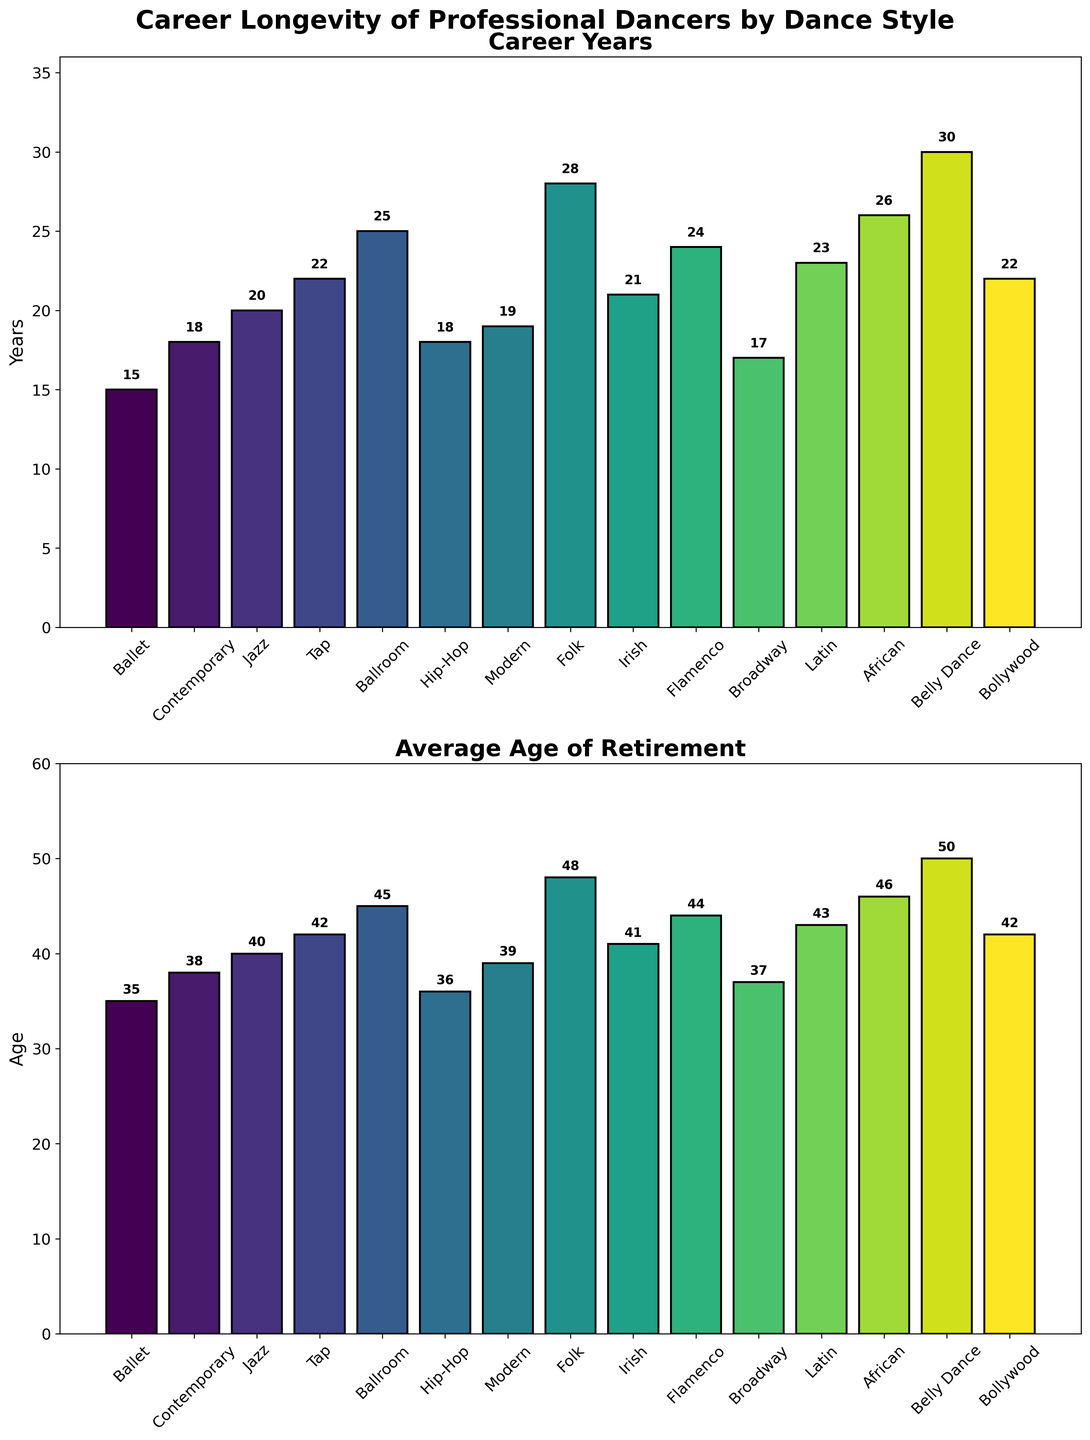What is the average career length for hip-hop dancers? Starting from the top figure, we find the bar for hip-hop. The bar indicates the career years for hip-hop dancers is 18.
Answer: 18 Which dance style has the highest average age of retirement? Looking at the bottom figure, the tallest bar represents the highest average age of retirement. The bar for Belly Dance is the tallest, indicating the age is 50.
Answer: Belly Dance, 50 Which dance styles have career lengths greater than 20 years? In the top figure, we identify bars that extend beyond the 20-year mark. These styles are Tap, Ballroom, Folk, Belly Dance, Flamenco, Latin, and African.
Answer: Tap, Ballroom, Folk, Belly Dance, Flamenco, Latin, African What is the difference in career length between Ballet and Contemporary dancers? From the top figure, we see that Ballet dancers have a career length of 15 years and Contemporary dancers have 18 years. The difference is calculated by subtracting 15 from 18, which equals 3.
Answer: 3 years How many dance styles have an average retirement age of 40 or above? In the bottom figure, we count the bars representing retirement ages of 40 or more. These styles are Jazz, Tap, Ballroom, Hip-Hop, Modern, Folk, Irish, Flamenco, Broadway, Latin, African, Belly Dance, Bollywood. Thus, there are 13 dance styles.
Answer: 13 styles Which dance style has the shortest career length, and what is it? In the top figure, the shortest bar represents the shortest career length. This is for Ballet, with a career length of 15 years.
Answer: Ballet, 15 years Compare the average age of retirement between Modern and Hip-Hop dancers. Which is greater? From the bottom figure, we find that Modern dancers retire at an average age of 39, while Hip-Hop dancers retire at an average age of 36. Therefore, Modern dancers have a greater average retirement age.
Answer: Modern, 39 What is the combined career length for Tap and Bollywood dancers? From the top figure, Tap dancers have a career length of 22 years and Bollywood dancers have a career length of 22 years. The combined length is 22 + 22 = 44 years.
Answer: 44 years Calculate the average career length across all dance styles. Summing up all career lengths from the top figure: 15 (Ballet) + 18 (Contemporary) + 20 (Jazz) + 22 (Tap) + 25 (Ballroom) + 18 (Hip-Hop) + 19 (Modern) + 28 (Folk) + 21 (Irish) + 24 (Flamenco) + 17 (Broadway) + 23 (Latin) + 26 (African) + 30 (Belly Dance) + 22 (Bollywood) = 338 years. Dividing by the number of dance styles (15), we get 338 / 15 ≈ 22.53 years.
Answer: 22.53 years 